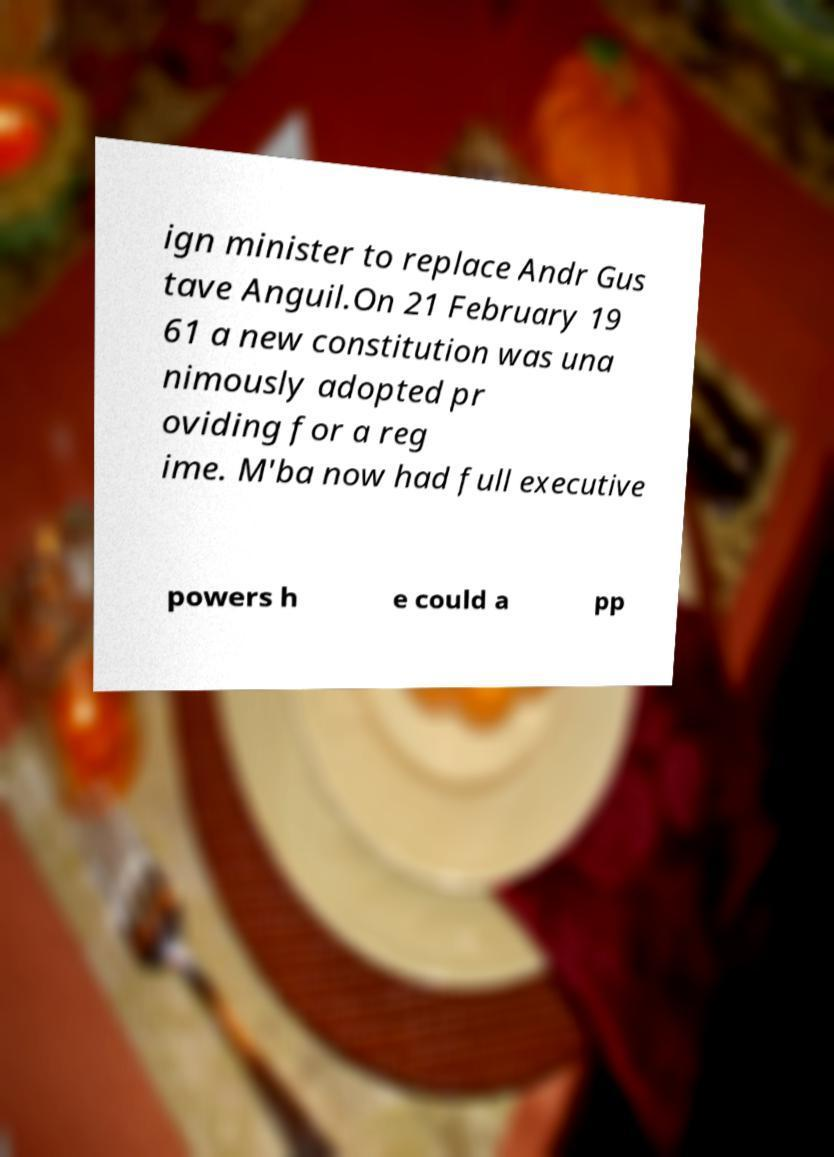For documentation purposes, I need the text within this image transcribed. Could you provide that? ign minister to replace Andr Gus tave Anguil.On 21 February 19 61 a new constitution was una nimously adopted pr oviding for a reg ime. M'ba now had full executive powers h e could a pp 